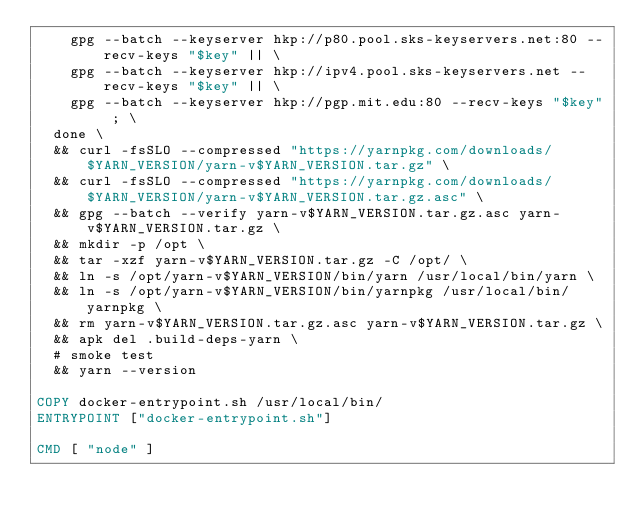<code> <loc_0><loc_0><loc_500><loc_500><_Dockerfile_>    gpg --batch --keyserver hkp://p80.pool.sks-keyservers.net:80 --recv-keys "$key" || \
    gpg --batch --keyserver hkp://ipv4.pool.sks-keyservers.net --recv-keys "$key" || \
    gpg --batch --keyserver hkp://pgp.mit.edu:80 --recv-keys "$key" ; \
  done \
  && curl -fsSLO --compressed "https://yarnpkg.com/downloads/$YARN_VERSION/yarn-v$YARN_VERSION.tar.gz" \
  && curl -fsSLO --compressed "https://yarnpkg.com/downloads/$YARN_VERSION/yarn-v$YARN_VERSION.tar.gz.asc" \
  && gpg --batch --verify yarn-v$YARN_VERSION.tar.gz.asc yarn-v$YARN_VERSION.tar.gz \
  && mkdir -p /opt \
  && tar -xzf yarn-v$YARN_VERSION.tar.gz -C /opt/ \
  && ln -s /opt/yarn-v$YARN_VERSION/bin/yarn /usr/local/bin/yarn \
  && ln -s /opt/yarn-v$YARN_VERSION/bin/yarnpkg /usr/local/bin/yarnpkg \
  && rm yarn-v$YARN_VERSION.tar.gz.asc yarn-v$YARN_VERSION.tar.gz \
  && apk del .build-deps-yarn \
  # smoke test
  && yarn --version

COPY docker-entrypoint.sh /usr/local/bin/
ENTRYPOINT ["docker-entrypoint.sh"]

CMD [ "node" ]
</code> 